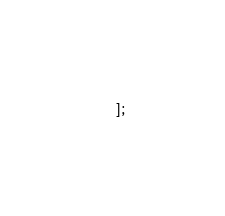Convert code to text. <code><loc_0><loc_0><loc_500><loc_500><_JavaScript_>];
</code> 